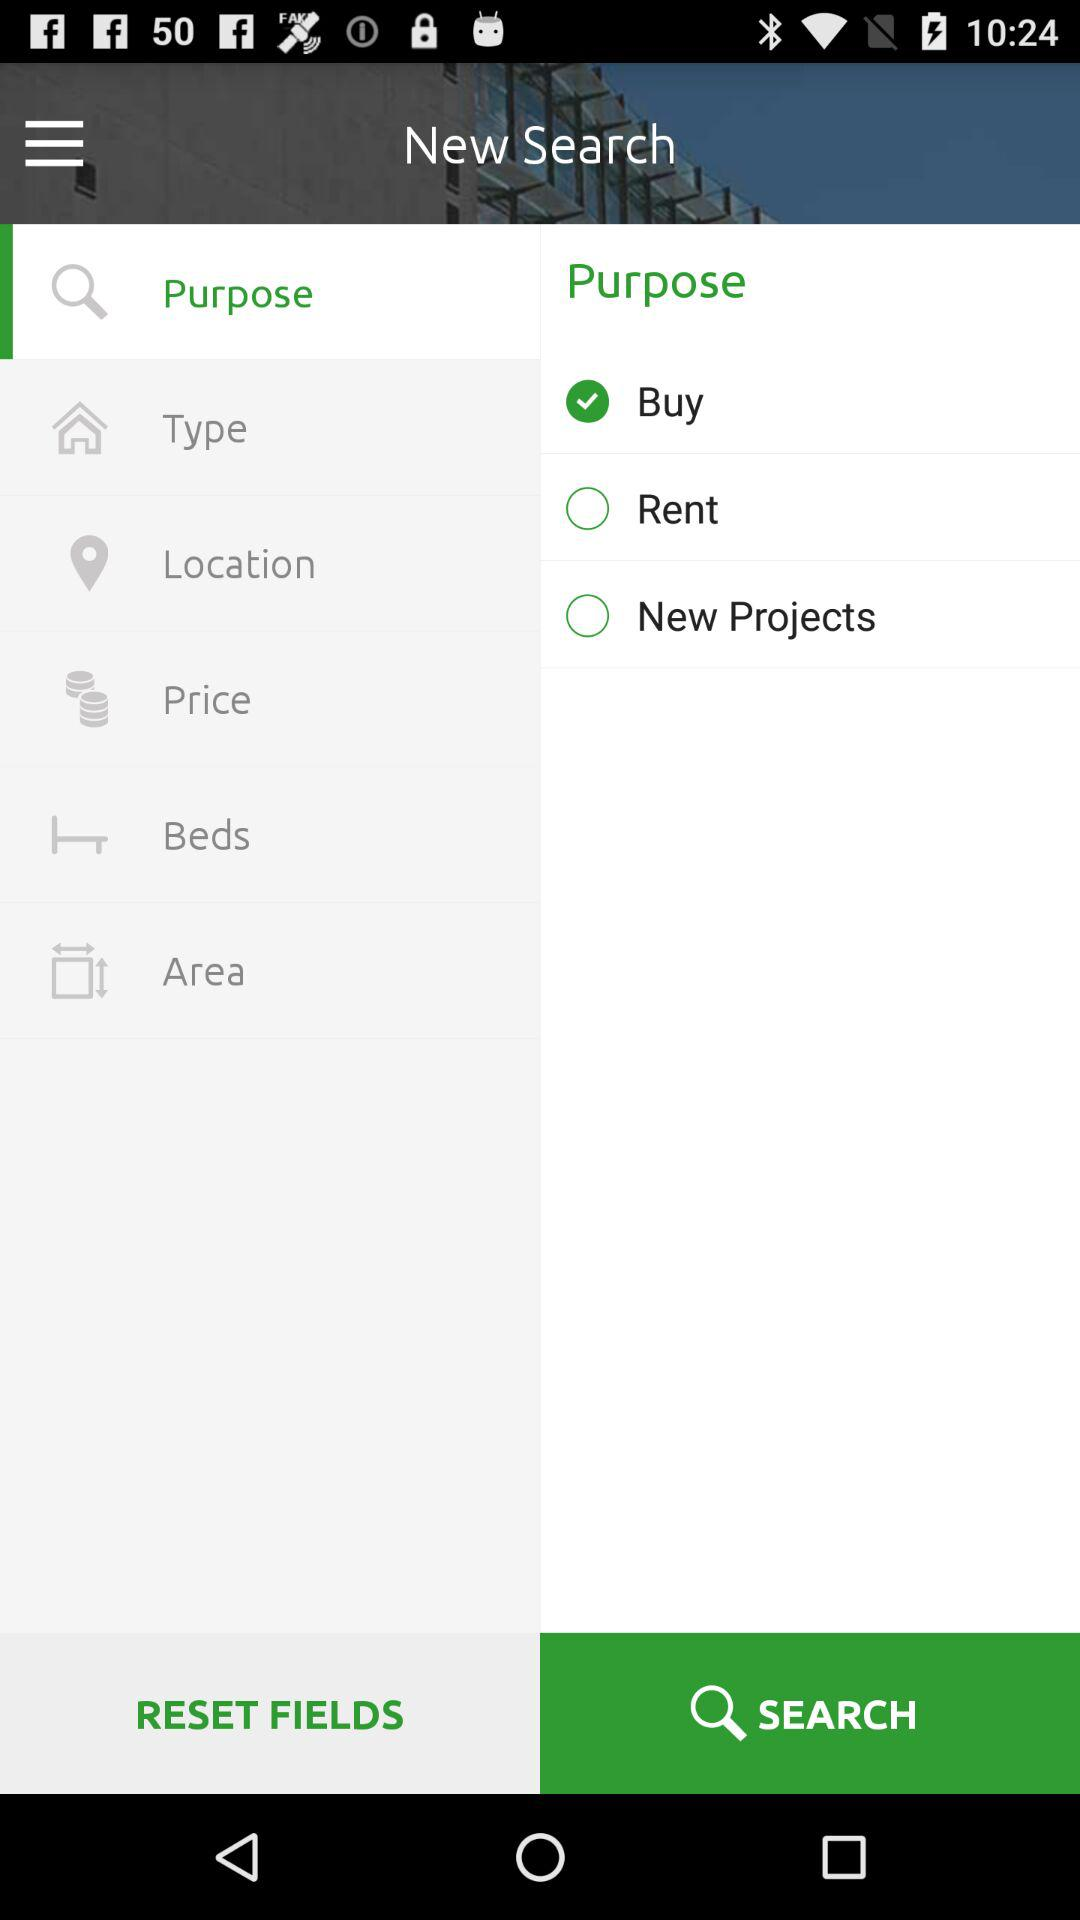What option is checked? The checked option is "Buy". 